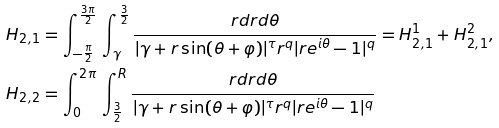Convert formula to latex. <formula><loc_0><loc_0><loc_500><loc_500>H _ { 2 , 1 } & = \int _ { - \frac { \pi } { 2 } } ^ { \frac { 3 \pi } { 2 } } \, \int _ { \gamma } ^ { \frac { 3 } { 2 } } \frac { r d r d \theta } { | \gamma + r \sin ( \theta + \varphi ) | ^ { \tau } r ^ { q } | r e ^ { i \theta } - 1 | ^ { q } } = H _ { 2 , 1 } ^ { 1 } + H _ { 2 , 1 } ^ { 2 } , \\ H _ { 2 , 2 } & = \int _ { 0 } ^ { 2 \pi } \, \int _ { \frac { 3 } { 2 } } ^ { R } \frac { r d r d \theta } { | \gamma + r \sin ( \theta + \varphi ) | ^ { \tau } r ^ { q } | r e ^ { i \theta } - 1 | ^ { q } }</formula> 